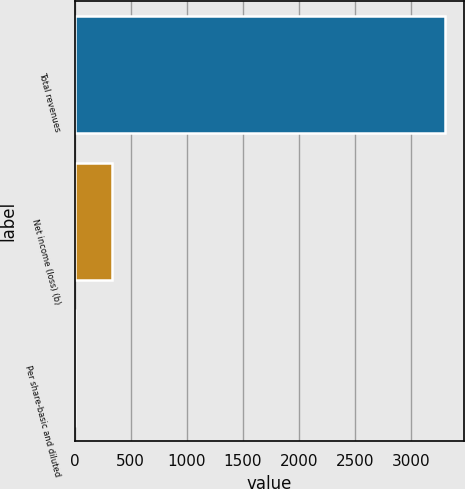Convert chart to OTSL. <chart><loc_0><loc_0><loc_500><loc_500><bar_chart><fcel>Total revenues<fcel>Net income (loss) (b)<fcel>Per share-basic and diluted<nl><fcel>3307<fcel>331.11<fcel>0.46<nl></chart> 